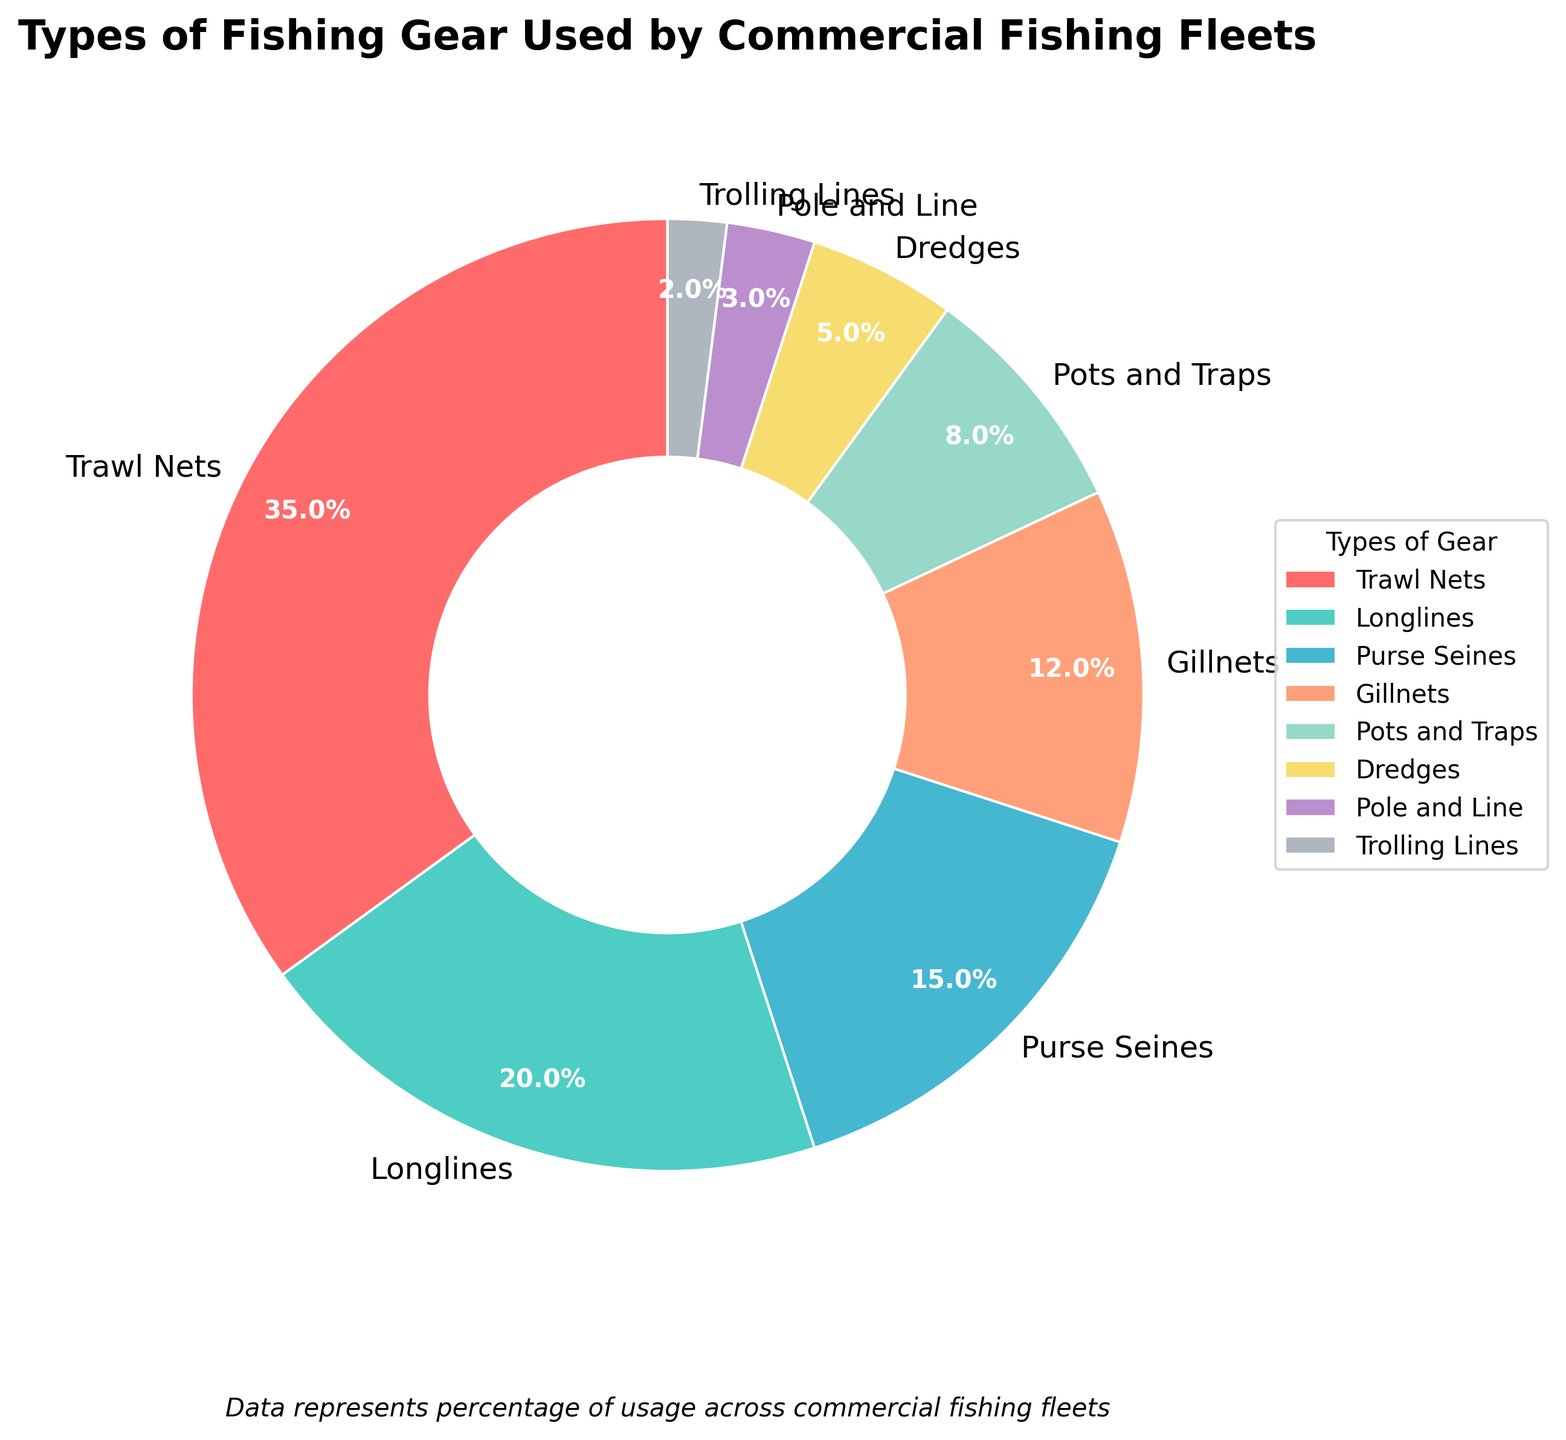Which type of fishing gear is used the most? The pie chart shows the percentage usage of different fishing gear types. Trawl Nets have the highest percentage at 35%.
Answer: Trawl Nets How much more are Trawl Nets used compared to Longlines? Trawl Nets are used 35% of the time, while Longlines are used 20% of the time. The difference is 35% - 20%.
Answer: 15% What is the combined usage percentage of Gillnets and Pots and Traps? Gillnets are used 12% and Pots and Traps are used 8%. Sum these percentages to get the combined usage. 12% + 8% = 20%.
Answer: 20% How does the usage of Purse Seines compare to that of Dredges? The usage of Purse Seines is 15%, whereas Dredges are used 5%. Purse Seines are used three times as much as Dredges.
Answer: Three times more Are there more types of fishing gear used less than 10%? Yes, both Trolling Lines (2%) and Pole and Line (3%) are used less than 10%. Trolling Lines and Pole and Line count as 2 such types.
Answer: Yes, 2 types Which type of gear is used the least, and what is its usage percentage? The pie chart indicates that Trolling Lines have the smallest percentage usage at 2%.
Answer: Trolling Lines, 2% What is the total percentage of usage for Trawl Nets, Longlines, and Purse Seines combined? Trawl Nets: 35%, Longlines: 20%, Purse Seines: 15%. Add these together: 35% + 20% + 15% = 70%.
Answer: 70% Are Gillnets used more or less than Longlines? By how much? Gillnets are used 12%, and Longlines are used 20%. Subtracting the percentages: 20% - 12% = 8%.
Answer: Less, by 8% What is the average usage percentage of Pots and Traps, Dredges, and Pole and Line? Add the percentages of Pots and Traps (8%), Dredges (5%), and Pole and Line (3%) and divide by 3: (8% + 5% + 3%) / 3 = 16% / 3 ≈ 5.33%.
Answer: Approximately 5.33% How much more used are Trawl Nets compared to the total usage of all gear types under 5%? Trawl Nets: 35%, sum of gear types under 5%: Trolling Lines (2%) + Pole and Line (3%) = 5%. Difference: 35% - 5% = 30%.
Answer: 30% more 